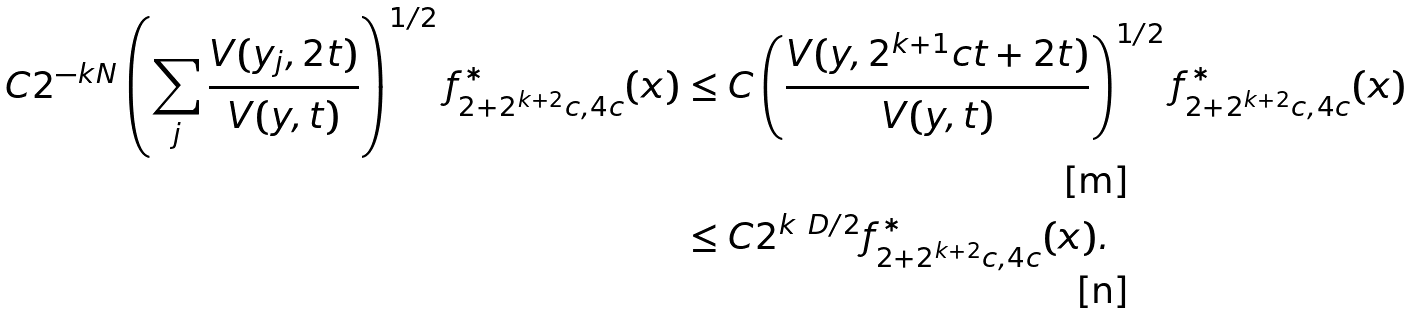<formula> <loc_0><loc_0><loc_500><loc_500>C 2 ^ { - k N } \left ( \sum _ { j } \frac { V ( y _ { j } , 2 t ) } { V ( y , t ) } \right ) ^ { 1 / 2 } f ^ { \ast } _ { 2 + 2 ^ { k + 2 } c , 4 c } ( x ) & \leq C \left ( \frac { V ( y , 2 ^ { k + 1 } c t + 2 t ) } { V ( y , t ) } \right ) ^ { 1 / 2 } f ^ { \ast } _ { 2 + 2 ^ { k + 2 } c , 4 c } ( x ) \\ & \leq C 2 ^ { k \ D / 2 } f ^ { \ast } _ { 2 + 2 ^ { k + 2 } c , 4 c } ( x ) .</formula> 